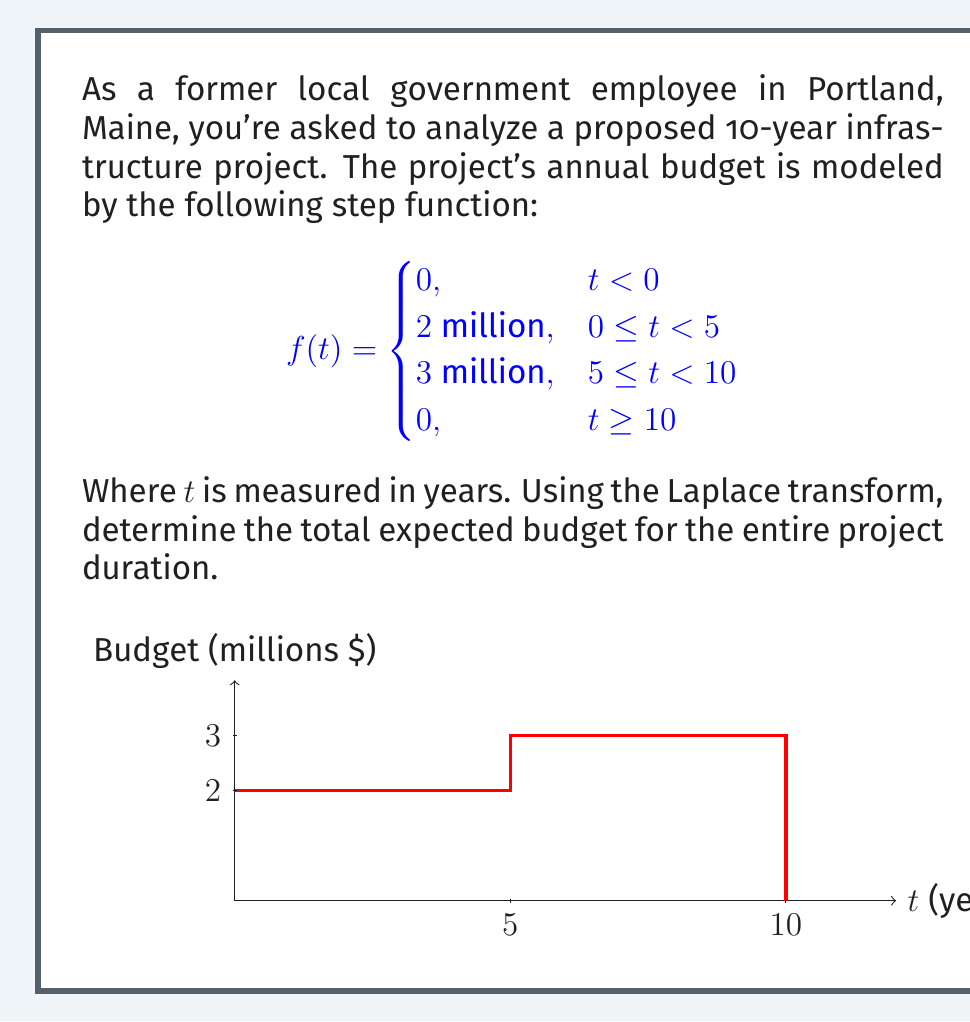Can you solve this math problem? Let's approach this step-by-step using Laplace transforms:

1) The Laplace transform of a step function $u(t-a)$ is $\frac{e^{-as}}{s}$.

2) We can express our function as a sum of step functions:
   $$f(t) = 2u(t) - 2u(t-5) + 3u(t-5) - 3u(t-10)$$

3) Taking the Laplace transform of each term:
   $$F(s) = \frac{2}{s} - \frac{2e^{-5s}}{s} + \frac{3e^{-5s}}{s} - \frac{3e^{-10s}}{s}$$

4) Simplifying:
   $$F(s) = \frac{2}{s} + \frac{e^{-5s}}{s} - \frac{3e^{-10s}}{s}$$

5) To find the total budget, we need to find $\lim_{s \to 0} sF(s)$:
   $$\lim_{s \to 0} sF(s) = \lim_{s \to 0} (2 + e^{-5s} - 3e^{-10s})$$

6) As $s \to 0$, $e^{-5s} \to 1$ and $e^{-10s} \to 1$:
   $$\lim_{s \to 0} sF(s) = 2 + 1 - 3 = 0$$

7) This result (0) represents the final value of $f(t)$ as $t \to \infty$, which is indeed 0.

8) To find the total budget, we need to integrate $f(t)$ from 0 to 10:
   $$\text{Total Budget} = \int_0^5 2 \, dt + \int_5^{10} 3 \, dt = 2(5) + 3(5) = 25$$

Therefore, the total expected budget for the entire project duration is 25 million dollars.
Answer: $25 million 